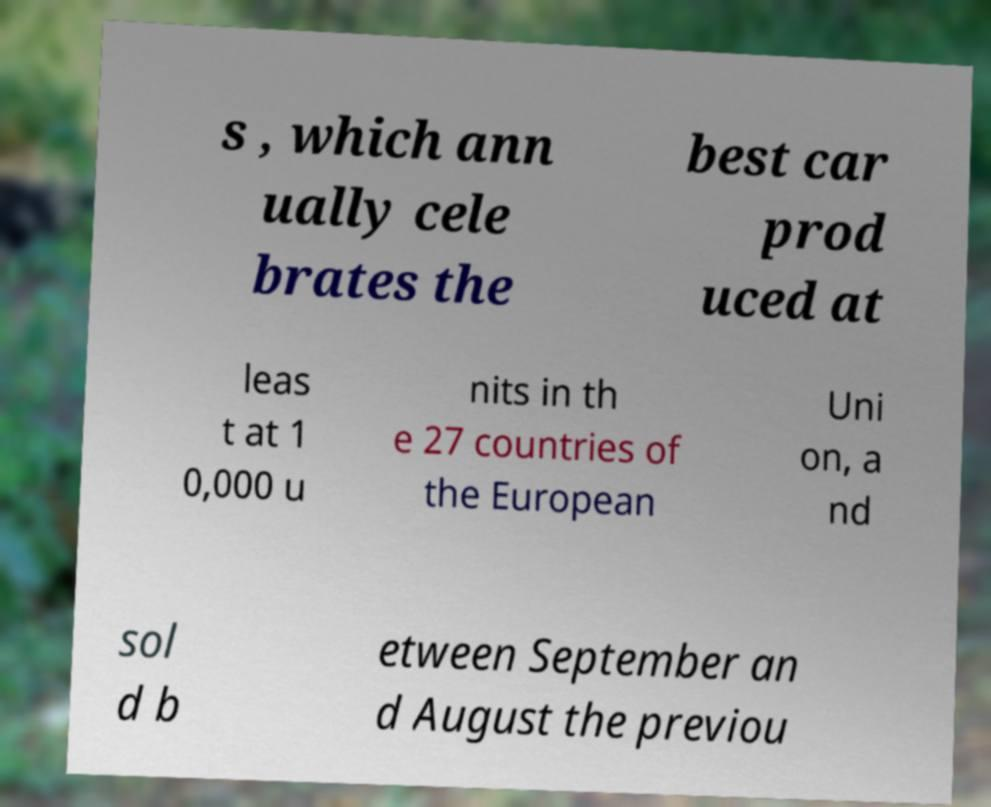Can you read and provide the text displayed in the image?This photo seems to have some interesting text. Can you extract and type it out for me? s , which ann ually cele brates the best car prod uced at leas t at 1 0,000 u nits in th e 27 countries of the European Uni on, a nd sol d b etween September an d August the previou 